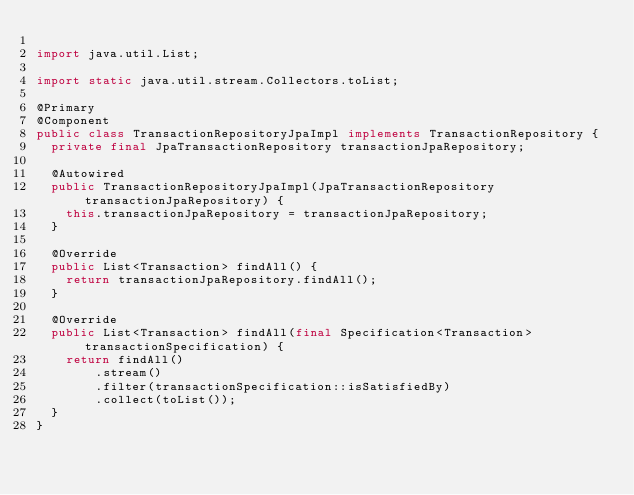<code> <loc_0><loc_0><loc_500><loc_500><_Java_>
import java.util.List;

import static java.util.stream.Collectors.toList;

@Primary
@Component
public class TransactionRepositoryJpaImpl implements TransactionRepository {
  private final JpaTransactionRepository transactionJpaRepository;

  @Autowired
  public TransactionRepositoryJpaImpl(JpaTransactionRepository transactionJpaRepository) {
    this.transactionJpaRepository = transactionJpaRepository;
  }

  @Override
  public List<Transaction> findAll() {
    return transactionJpaRepository.findAll();
  }

  @Override
  public List<Transaction> findAll(final Specification<Transaction> transactionSpecification) {
    return findAll()
        .stream()
        .filter(transactionSpecification::isSatisfiedBy)
        .collect(toList());
  }
}
</code> 